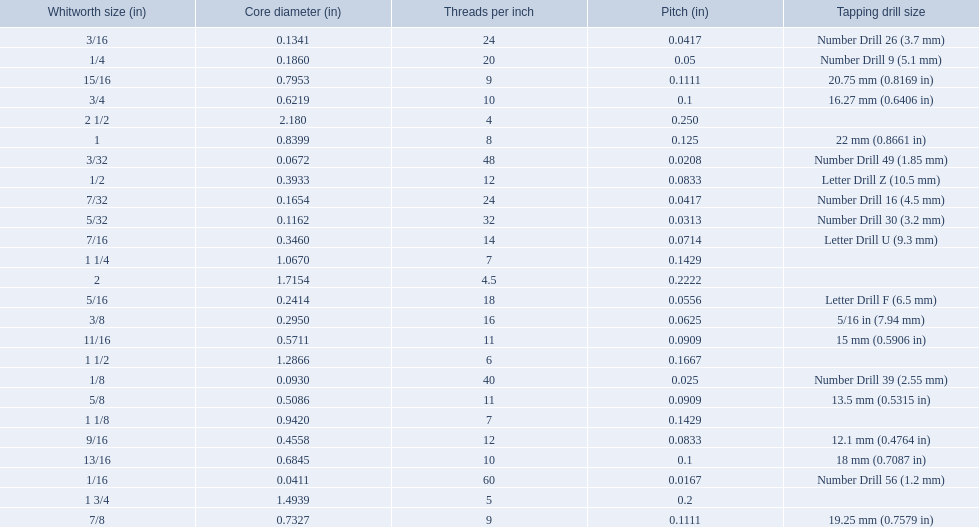What was the core diameter of a number drill 26 0.1341. What is this measurement in whitworth size? 3/16. 